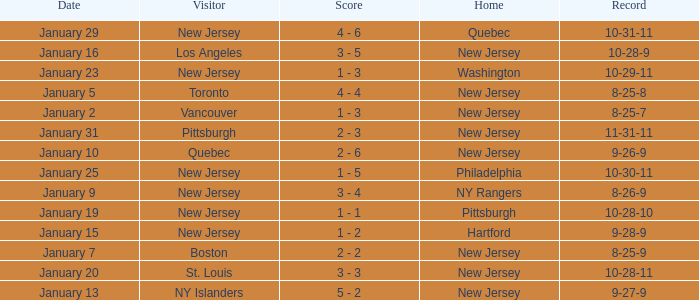What was the home team when the visiting team was Toronto? New Jersey. 